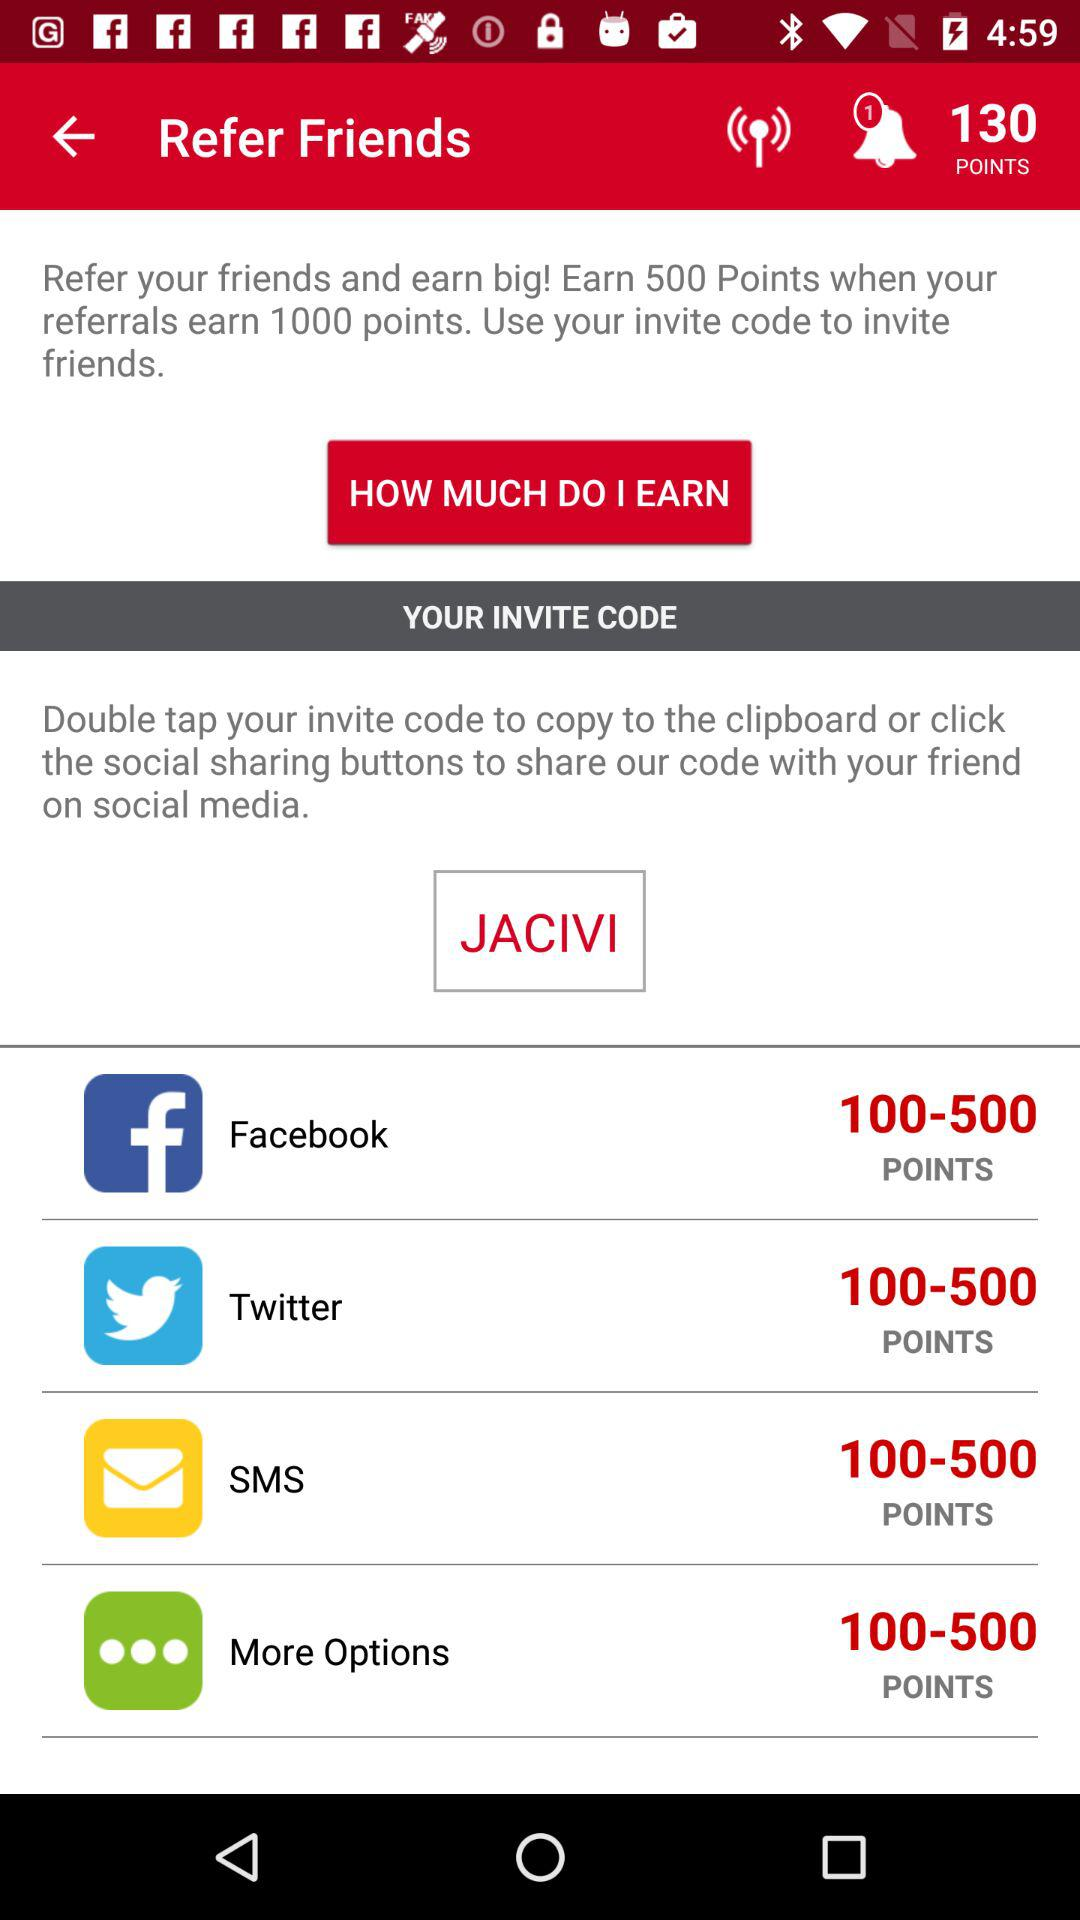How many points do I earn when my referral earns 1000 points?
Answer the question using a single word or phrase. 500 